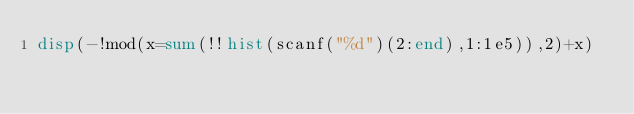Convert code to text. <code><loc_0><loc_0><loc_500><loc_500><_Octave_>disp(-!mod(x=sum(!!hist(scanf("%d")(2:end),1:1e5)),2)+x)</code> 